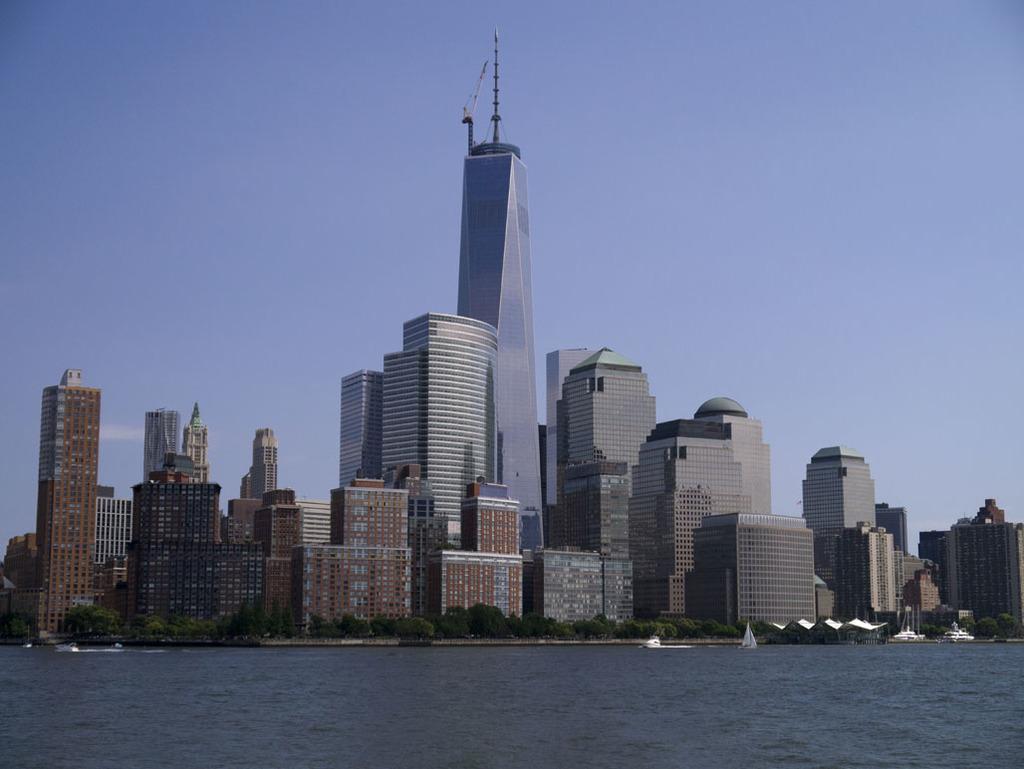Please provide a concise description of this image. In this image there is a river at the bottom. Behind the river there are tall buildings. There are trees near the buildings. At the top there is sky. 